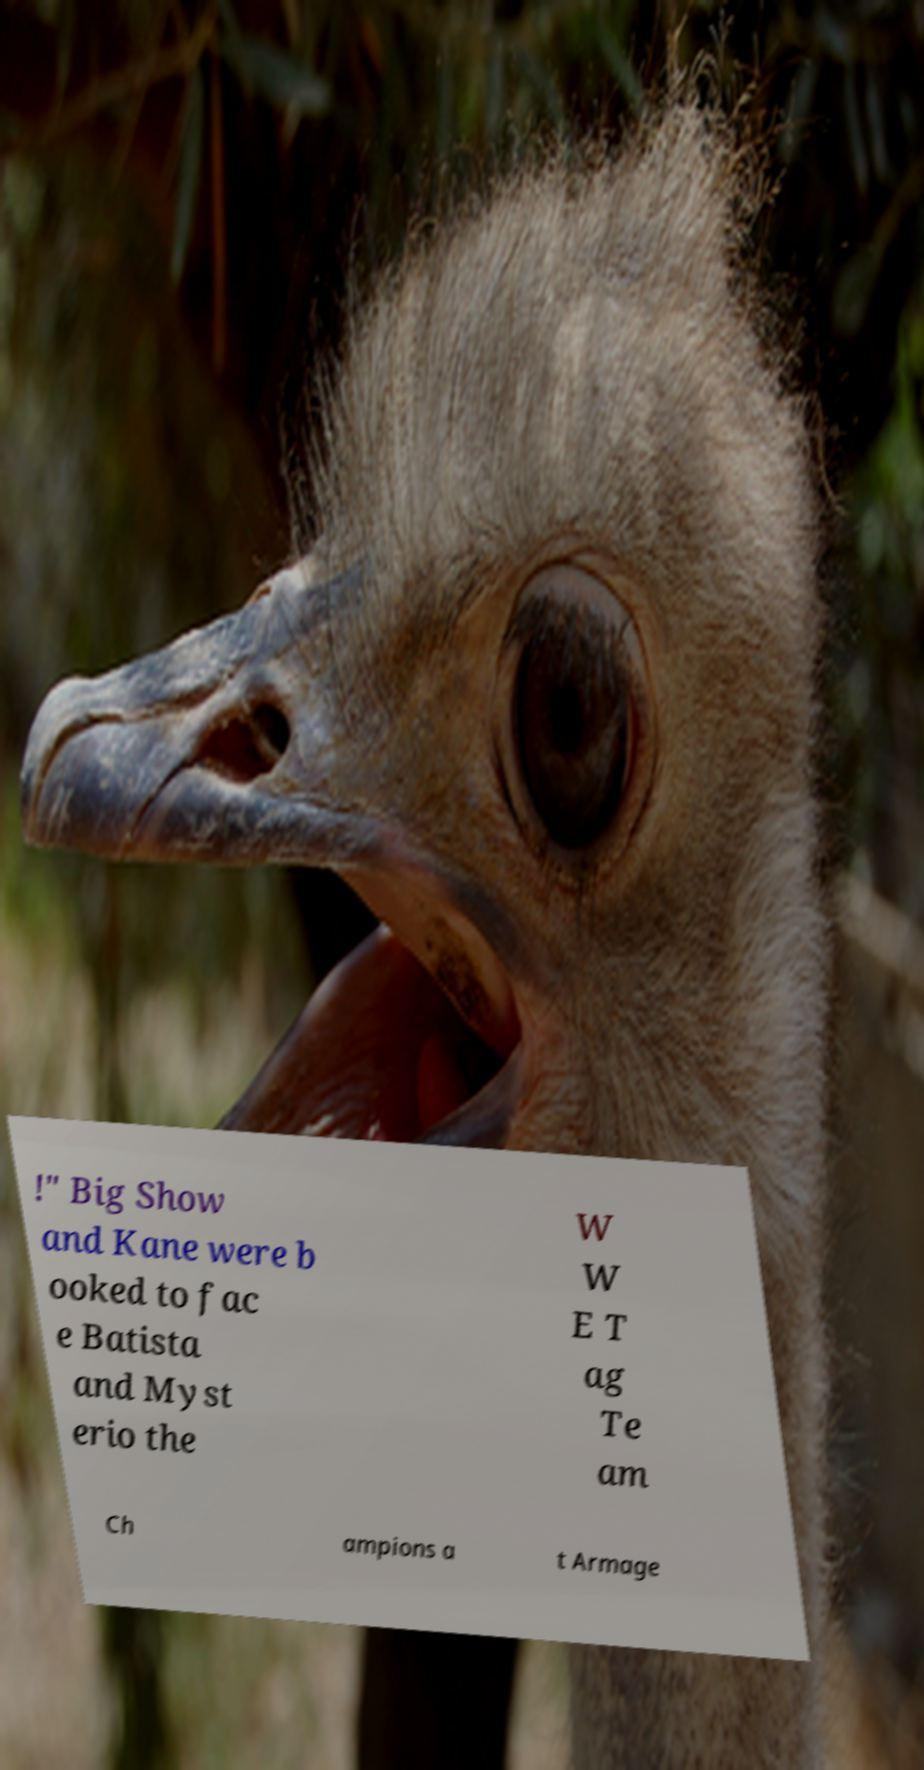Could you extract and type out the text from this image? !" Big Show and Kane were b ooked to fac e Batista and Myst erio the W W E T ag Te am Ch ampions a t Armage 